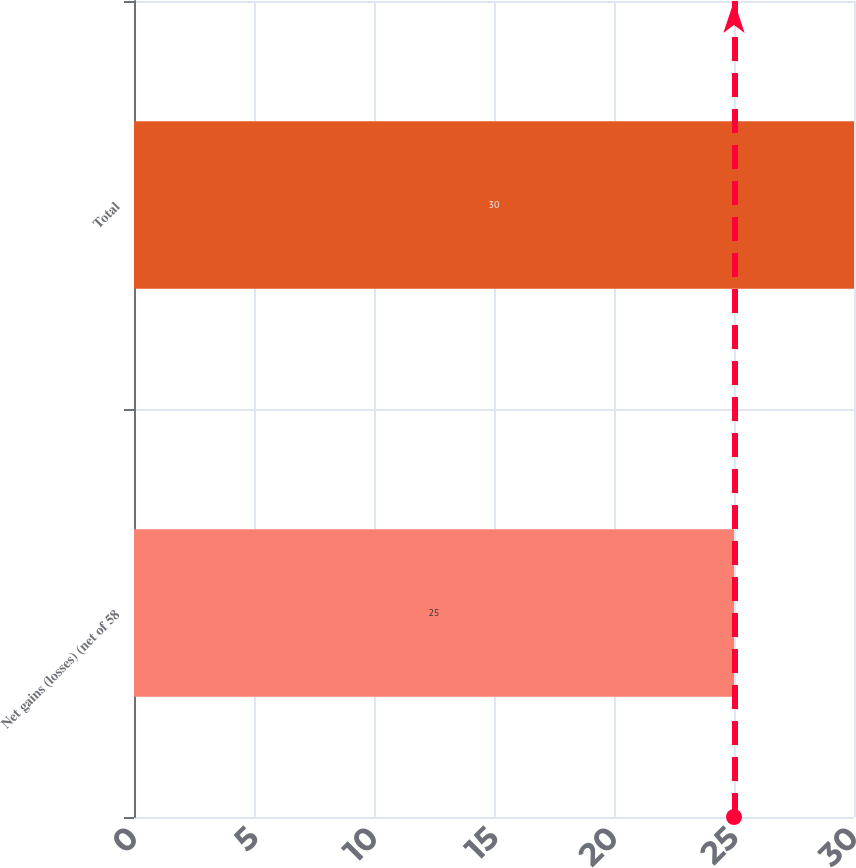<chart> <loc_0><loc_0><loc_500><loc_500><bar_chart><fcel>Net gains (losses) (net of 58<fcel>Total<nl><fcel>25<fcel>30<nl></chart> 